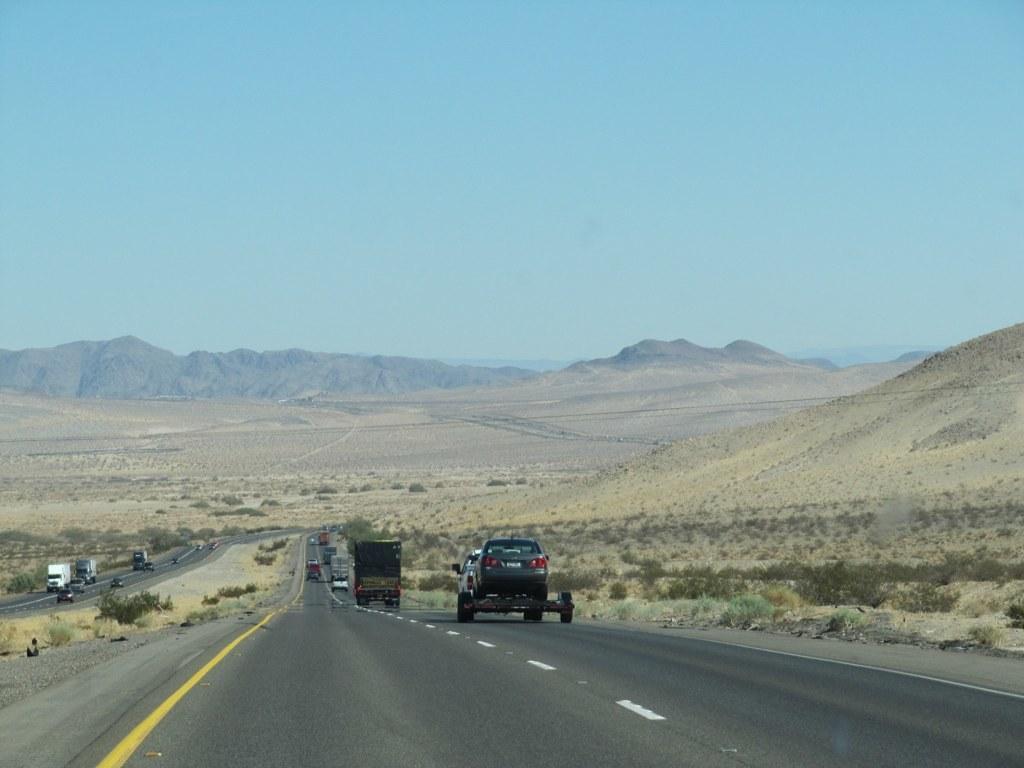Can you describe this image briefly? In this image there are a few vehicles moving on the roads, there are a few plants, mountains and in the background there is the sky. 